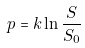<formula> <loc_0><loc_0><loc_500><loc_500>p = k \ln \frac { S } { S _ { 0 } }</formula> 